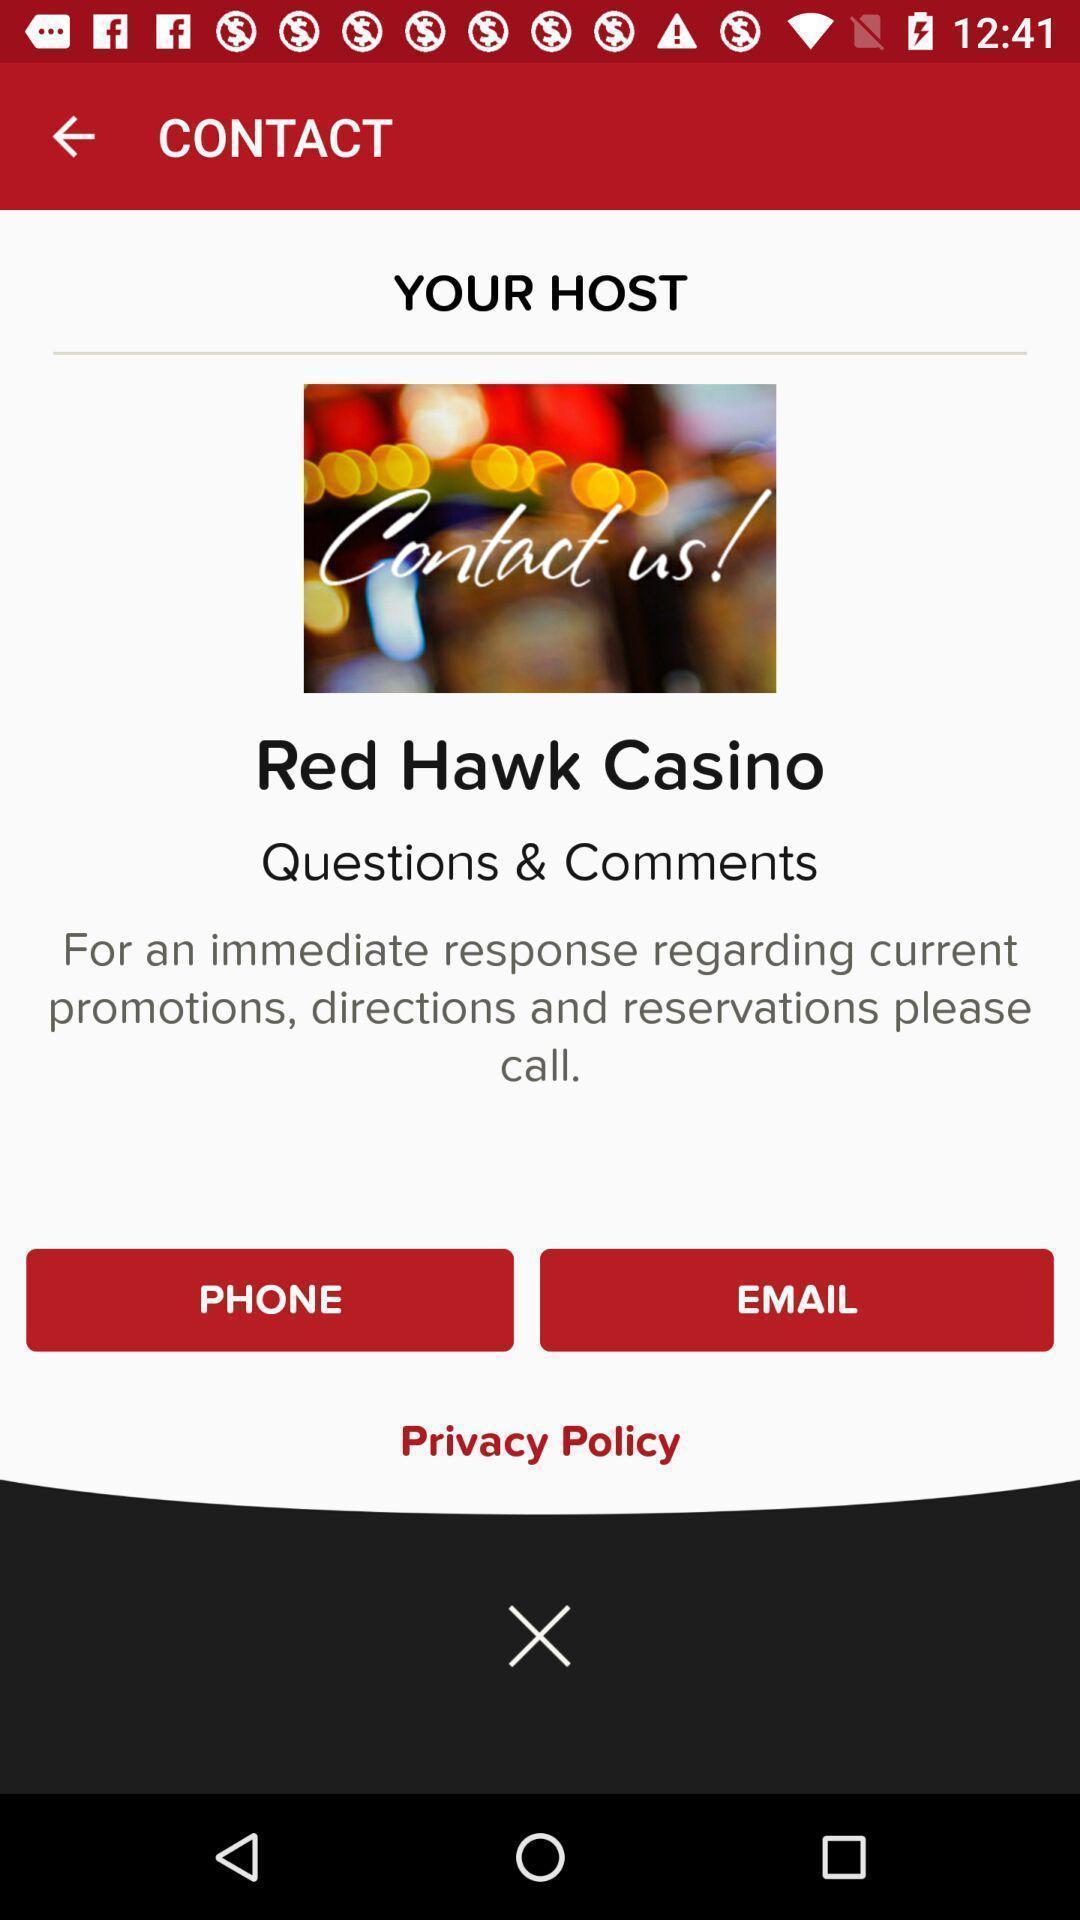Provide a description of this screenshot. Page to contact through various options in application. 